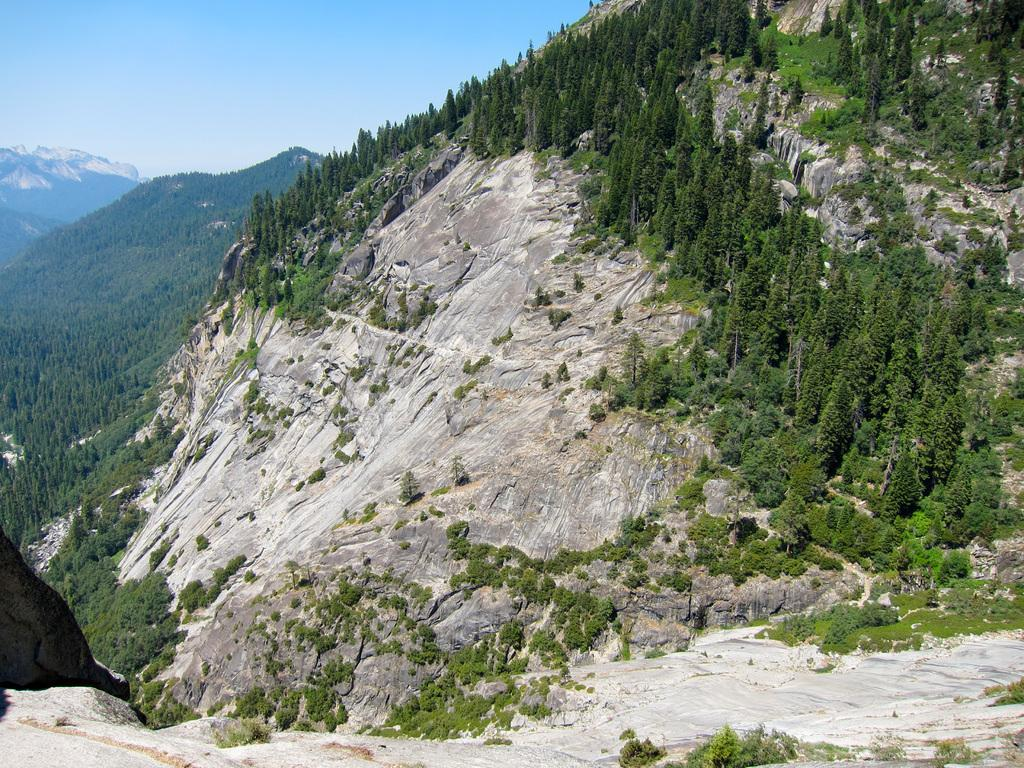What type of natural elements can be seen in the image? There are many trees, plants, and rocks in the image. What is visible in the background of the image? The background of the image includes hills and the sky. What is the condition of the sky in the image? The sky is visible in the background of the image, and it is clear. How many friends are present in the image? There is no reference to friends in the image, as it features natural elements such as trees, plants, rocks, hills, and the sky. 